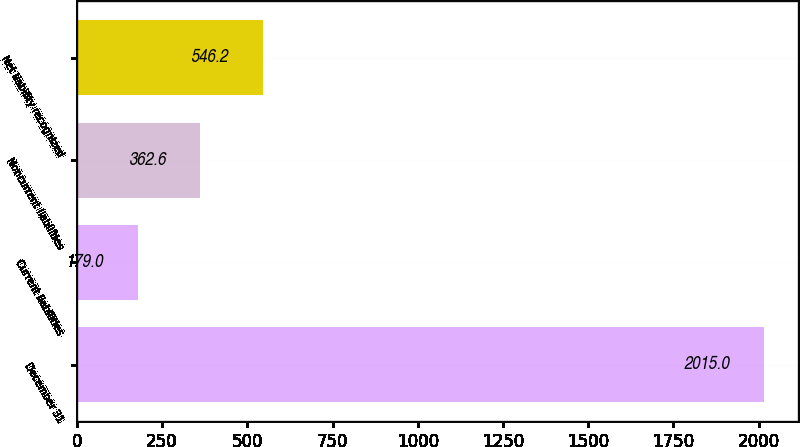Convert chart to OTSL. <chart><loc_0><loc_0><loc_500><loc_500><bar_chart><fcel>December 31<fcel>Current liabilities<fcel>Noncurrent liabilities<fcel>Net liability recognized<nl><fcel>2015<fcel>179<fcel>362.6<fcel>546.2<nl></chart> 